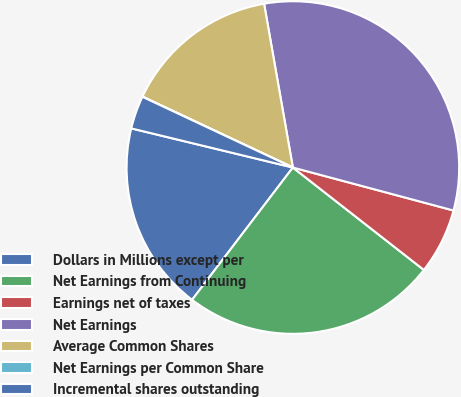Convert chart. <chart><loc_0><loc_0><loc_500><loc_500><pie_chart><fcel>Dollars in Millions except per<fcel>Net Earnings from Continuing<fcel>Earnings net of taxes<fcel>Net Earnings<fcel>Average Common Shares<fcel>Net Earnings per Common Share<fcel>Incremental shares outstanding<nl><fcel>18.42%<fcel>24.8%<fcel>6.4%<fcel>31.93%<fcel>15.22%<fcel>0.02%<fcel>3.21%<nl></chart> 